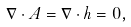<formula> <loc_0><loc_0><loc_500><loc_500>\nabla \cdot A = \nabla \cdot h = 0 ,</formula> 